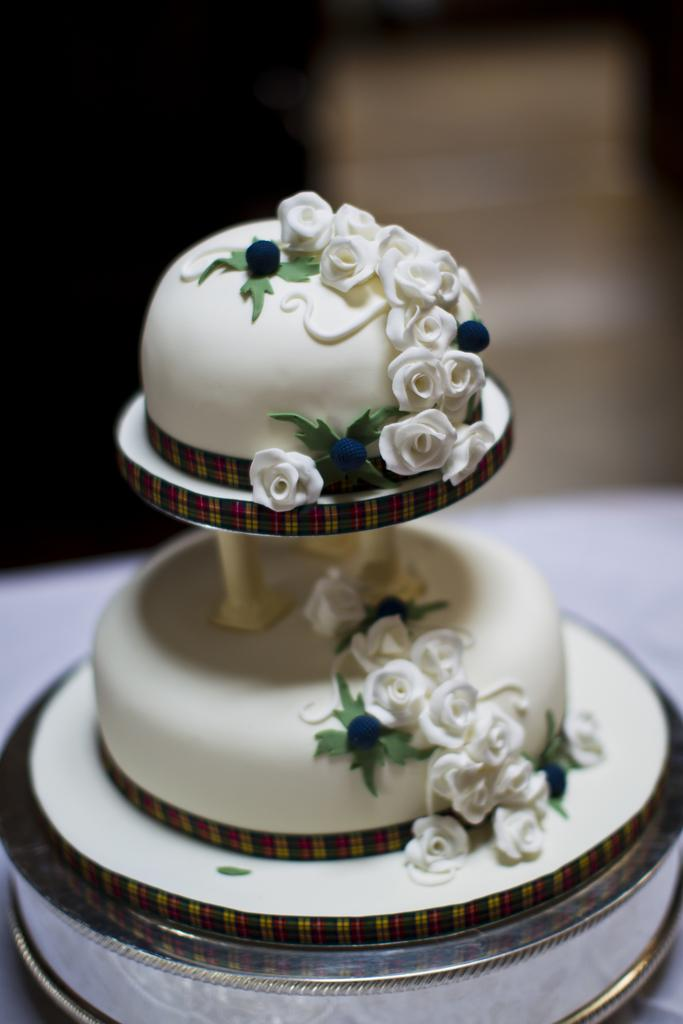What type of cake is shown in the image? There is a stepped cake in the image. Where is the cake located? The cake is present on a table. What decorations are on the cake? The cake has flower designs on it. What advertisement is being displayed on the cake in the image? There is no advertisement displayed on the cake in the image; it only has flower designs. 